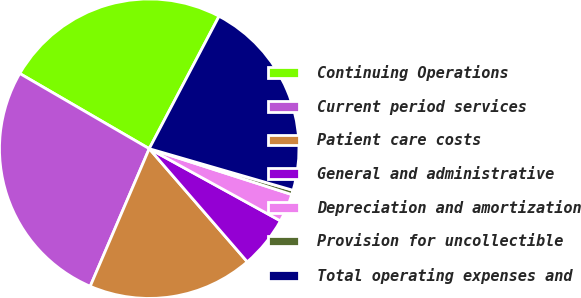Convert chart to OTSL. <chart><loc_0><loc_0><loc_500><loc_500><pie_chart><fcel>Continuing Operations<fcel>Current period services<fcel>Patient care costs<fcel>General and administrative<fcel>Depreciation and amortization<fcel>Provision for uncollectible<fcel>Total operating expenses and<nl><fcel>24.34%<fcel>26.92%<fcel>17.81%<fcel>5.63%<fcel>3.05%<fcel>0.47%<fcel>21.76%<nl></chart> 